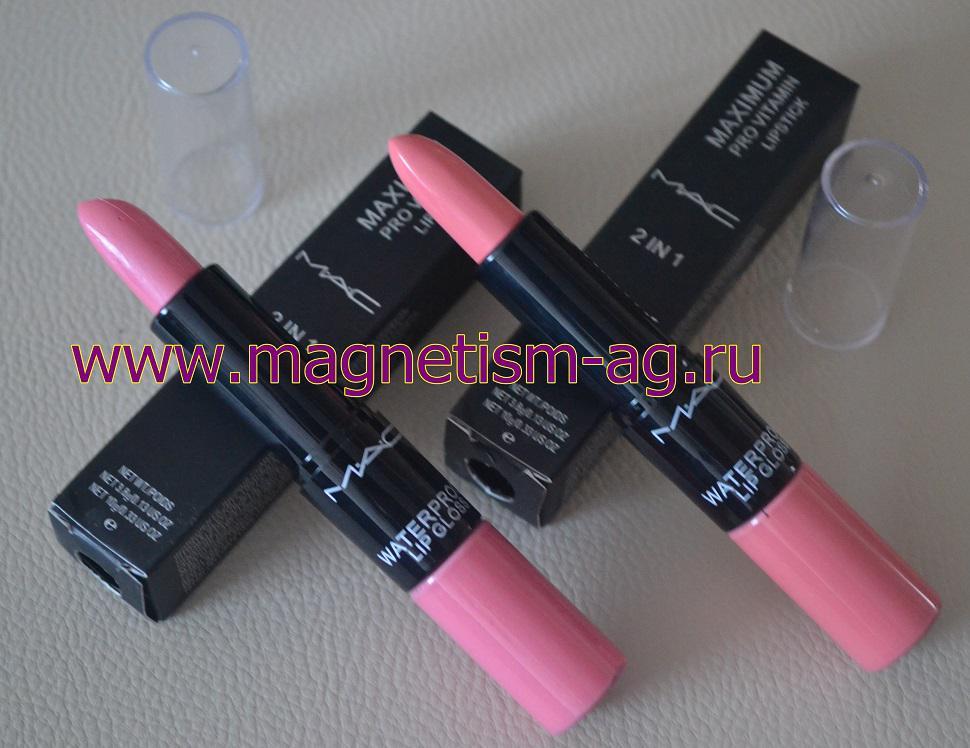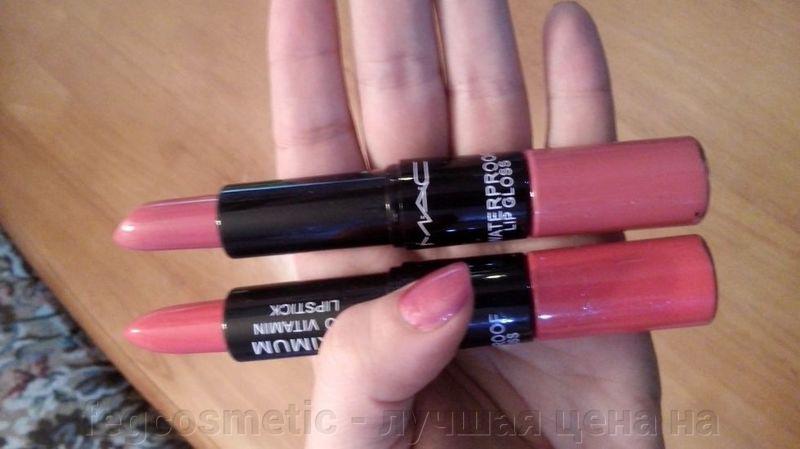The first image is the image on the left, the second image is the image on the right. Given the left and right images, does the statement "An image shows a lipstick by colored lips." hold true? Answer yes or no. No. 